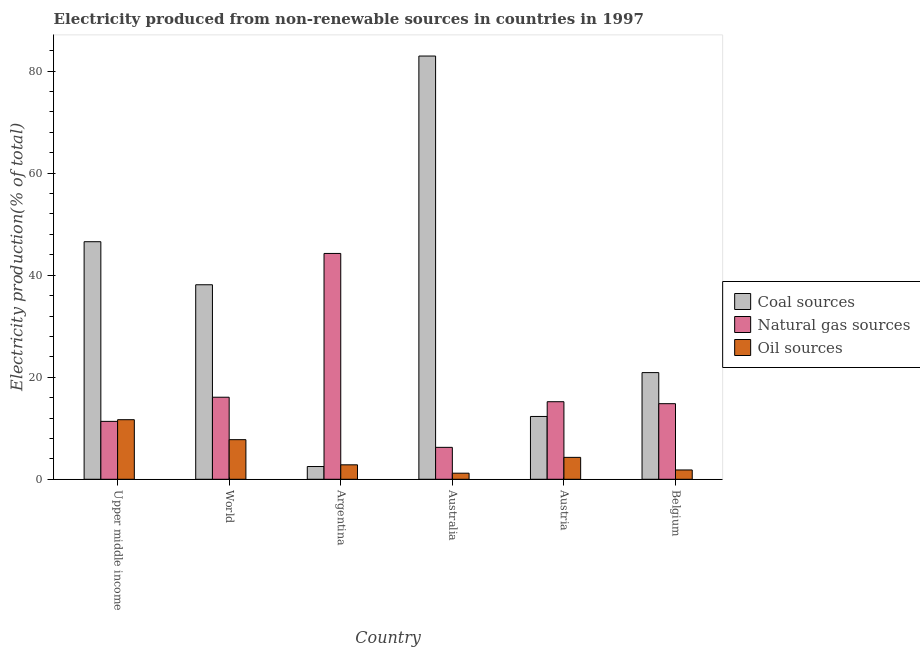Are the number of bars per tick equal to the number of legend labels?
Your response must be concise. Yes. Are the number of bars on each tick of the X-axis equal?
Offer a very short reply. Yes. How many bars are there on the 6th tick from the right?
Offer a terse response. 3. In how many cases, is the number of bars for a given country not equal to the number of legend labels?
Your answer should be very brief. 0. What is the percentage of electricity produced by coal in Argentina?
Make the answer very short. 2.5. Across all countries, what is the maximum percentage of electricity produced by natural gas?
Your answer should be very brief. 44.27. Across all countries, what is the minimum percentage of electricity produced by coal?
Provide a short and direct response. 2.5. In which country was the percentage of electricity produced by oil sources maximum?
Your answer should be compact. Upper middle income. What is the total percentage of electricity produced by natural gas in the graph?
Your answer should be very brief. 107.98. What is the difference between the percentage of electricity produced by oil sources in Argentina and that in Australia?
Your answer should be compact. 1.64. What is the difference between the percentage of electricity produced by natural gas in World and the percentage of electricity produced by oil sources in Austria?
Your response must be concise. 11.79. What is the average percentage of electricity produced by oil sources per country?
Your answer should be compact. 4.93. What is the difference between the percentage of electricity produced by natural gas and percentage of electricity produced by oil sources in Belgium?
Provide a succinct answer. 12.99. In how many countries, is the percentage of electricity produced by oil sources greater than 76 %?
Provide a short and direct response. 0. What is the ratio of the percentage of electricity produced by natural gas in Argentina to that in Austria?
Keep it short and to the point. 2.91. What is the difference between the highest and the second highest percentage of electricity produced by coal?
Offer a terse response. 36.4. What is the difference between the highest and the lowest percentage of electricity produced by natural gas?
Offer a terse response. 38.01. What does the 2nd bar from the left in Upper middle income represents?
Make the answer very short. Natural gas sources. What does the 3rd bar from the right in Austria represents?
Give a very brief answer. Coal sources. Is it the case that in every country, the sum of the percentage of electricity produced by coal and percentage of electricity produced by natural gas is greater than the percentage of electricity produced by oil sources?
Your answer should be very brief. Yes. How many bars are there?
Make the answer very short. 18. What is the difference between two consecutive major ticks on the Y-axis?
Ensure brevity in your answer.  20. Are the values on the major ticks of Y-axis written in scientific E-notation?
Your response must be concise. No. Does the graph contain grids?
Offer a terse response. No. Where does the legend appear in the graph?
Provide a succinct answer. Center right. How many legend labels are there?
Give a very brief answer. 3. How are the legend labels stacked?
Provide a short and direct response. Vertical. What is the title of the graph?
Ensure brevity in your answer.  Electricity produced from non-renewable sources in countries in 1997. Does "Secondary" appear as one of the legend labels in the graph?
Provide a succinct answer. No. What is the label or title of the X-axis?
Your answer should be compact. Country. What is the label or title of the Y-axis?
Make the answer very short. Electricity production(% of total). What is the Electricity production(% of total) of Coal sources in Upper middle income?
Your answer should be compact. 46.57. What is the Electricity production(% of total) in Natural gas sources in Upper middle income?
Give a very brief answer. 11.35. What is the Electricity production(% of total) of Oil sources in Upper middle income?
Ensure brevity in your answer.  11.68. What is the Electricity production(% of total) of Coal sources in World?
Offer a terse response. 38.13. What is the Electricity production(% of total) of Natural gas sources in World?
Your response must be concise. 16.08. What is the Electricity production(% of total) in Oil sources in World?
Keep it short and to the point. 7.76. What is the Electricity production(% of total) of Coal sources in Argentina?
Give a very brief answer. 2.5. What is the Electricity production(% of total) in Natural gas sources in Argentina?
Keep it short and to the point. 44.27. What is the Electricity production(% of total) of Oil sources in Argentina?
Provide a short and direct response. 2.83. What is the Electricity production(% of total) in Coal sources in Australia?
Ensure brevity in your answer.  82.96. What is the Electricity production(% of total) in Natural gas sources in Australia?
Your answer should be compact. 6.26. What is the Electricity production(% of total) in Oil sources in Australia?
Provide a succinct answer. 1.19. What is the Electricity production(% of total) of Coal sources in Austria?
Provide a short and direct response. 12.31. What is the Electricity production(% of total) in Natural gas sources in Austria?
Ensure brevity in your answer.  15.2. What is the Electricity production(% of total) in Oil sources in Austria?
Provide a succinct answer. 4.29. What is the Electricity production(% of total) of Coal sources in Belgium?
Your response must be concise. 20.91. What is the Electricity production(% of total) in Natural gas sources in Belgium?
Offer a terse response. 14.82. What is the Electricity production(% of total) in Oil sources in Belgium?
Your response must be concise. 1.83. Across all countries, what is the maximum Electricity production(% of total) of Coal sources?
Your answer should be very brief. 82.96. Across all countries, what is the maximum Electricity production(% of total) of Natural gas sources?
Keep it short and to the point. 44.27. Across all countries, what is the maximum Electricity production(% of total) of Oil sources?
Keep it short and to the point. 11.68. Across all countries, what is the minimum Electricity production(% of total) of Coal sources?
Provide a short and direct response. 2.5. Across all countries, what is the minimum Electricity production(% of total) in Natural gas sources?
Provide a short and direct response. 6.26. Across all countries, what is the minimum Electricity production(% of total) of Oil sources?
Provide a short and direct response. 1.19. What is the total Electricity production(% of total) in Coal sources in the graph?
Your answer should be very brief. 203.38. What is the total Electricity production(% of total) of Natural gas sources in the graph?
Provide a succinct answer. 107.98. What is the total Electricity production(% of total) of Oil sources in the graph?
Keep it short and to the point. 29.59. What is the difference between the Electricity production(% of total) of Coal sources in Upper middle income and that in World?
Provide a short and direct response. 8.44. What is the difference between the Electricity production(% of total) in Natural gas sources in Upper middle income and that in World?
Provide a succinct answer. -4.73. What is the difference between the Electricity production(% of total) of Oil sources in Upper middle income and that in World?
Give a very brief answer. 3.92. What is the difference between the Electricity production(% of total) in Coal sources in Upper middle income and that in Argentina?
Provide a short and direct response. 44.07. What is the difference between the Electricity production(% of total) of Natural gas sources in Upper middle income and that in Argentina?
Provide a succinct answer. -32.92. What is the difference between the Electricity production(% of total) of Oil sources in Upper middle income and that in Argentina?
Make the answer very short. 8.85. What is the difference between the Electricity production(% of total) of Coal sources in Upper middle income and that in Australia?
Offer a terse response. -36.4. What is the difference between the Electricity production(% of total) in Natural gas sources in Upper middle income and that in Australia?
Your answer should be very brief. 5.09. What is the difference between the Electricity production(% of total) in Oil sources in Upper middle income and that in Australia?
Offer a very short reply. 10.49. What is the difference between the Electricity production(% of total) in Coal sources in Upper middle income and that in Austria?
Make the answer very short. 34.25. What is the difference between the Electricity production(% of total) in Natural gas sources in Upper middle income and that in Austria?
Keep it short and to the point. -3.85. What is the difference between the Electricity production(% of total) of Oil sources in Upper middle income and that in Austria?
Make the answer very short. 7.39. What is the difference between the Electricity production(% of total) in Coal sources in Upper middle income and that in Belgium?
Make the answer very short. 25.65. What is the difference between the Electricity production(% of total) of Natural gas sources in Upper middle income and that in Belgium?
Give a very brief answer. -3.47. What is the difference between the Electricity production(% of total) of Oil sources in Upper middle income and that in Belgium?
Ensure brevity in your answer.  9.85. What is the difference between the Electricity production(% of total) of Coal sources in World and that in Argentina?
Ensure brevity in your answer.  35.63. What is the difference between the Electricity production(% of total) in Natural gas sources in World and that in Argentina?
Your answer should be very brief. -28.18. What is the difference between the Electricity production(% of total) in Oil sources in World and that in Argentina?
Your answer should be very brief. 4.93. What is the difference between the Electricity production(% of total) of Coal sources in World and that in Australia?
Your answer should be compact. -44.84. What is the difference between the Electricity production(% of total) in Natural gas sources in World and that in Australia?
Give a very brief answer. 9.82. What is the difference between the Electricity production(% of total) of Oil sources in World and that in Australia?
Make the answer very short. 6.57. What is the difference between the Electricity production(% of total) of Coal sources in World and that in Austria?
Ensure brevity in your answer.  25.81. What is the difference between the Electricity production(% of total) of Natural gas sources in World and that in Austria?
Ensure brevity in your answer.  0.88. What is the difference between the Electricity production(% of total) of Oil sources in World and that in Austria?
Your answer should be compact. 3.47. What is the difference between the Electricity production(% of total) of Coal sources in World and that in Belgium?
Ensure brevity in your answer.  17.22. What is the difference between the Electricity production(% of total) in Natural gas sources in World and that in Belgium?
Ensure brevity in your answer.  1.26. What is the difference between the Electricity production(% of total) in Oil sources in World and that in Belgium?
Offer a very short reply. 5.94. What is the difference between the Electricity production(% of total) of Coal sources in Argentina and that in Australia?
Give a very brief answer. -80.46. What is the difference between the Electricity production(% of total) of Natural gas sources in Argentina and that in Australia?
Keep it short and to the point. 38.01. What is the difference between the Electricity production(% of total) in Oil sources in Argentina and that in Australia?
Give a very brief answer. 1.64. What is the difference between the Electricity production(% of total) of Coal sources in Argentina and that in Austria?
Provide a succinct answer. -9.81. What is the difference between the Electricity production(% of total) in Natural gas sources in Argentina and that in Austria?
Your answer should be compact. 29.06. What is the difference between the Electricity production(% of total) in Oil sources in Argentina and that in Austria?
Ensure brevity in your answer.  -1.46. What is the difference between the Electricity production(% of total) in Coal sources in Argentina and that in Belgium?
Give a very brief answer. -18.41. What is the difference between the Electricity production(% of total) of Natural gas sources in Argentina and that in Belgium?
Provide a short and direct response. 29.45. What is the difference between the Electricity production(% of total) of Oil sources in Argentina and that in Belgium?
Your answer should be very brief. 1.01. What is the difference between the Electricity production(% of total) in Coal sources in Australia and that in Austria?
Give a very brief answer. 70.65. What is the difference between the Electricity production(% of total) of Natural gas sources in Australia and that in Austria?
Offer a terse response. -8.95. What is the difference between the Electricity production(% of total) in Oil sources in Australia and that in Austria?
Provide a succinct answer. -3.1. What is the difference between the Electricity production(% of total) in Coal sources in Australia and that in Belgium?
Make the answer very short. 62.05. What is the difference between the Electricity production(% of total) of Natural gas sources in Australia and that in Belgium?
Your answer should be compact. -8.56. What is the difference between the Electricity production(% of total) of Oil sources in Australia and that in Belgium?
Your answer should be compact. -0.64. What is the difference between the Electricity production(% of total) in Coal sources in Austria and that in Belgium?
Keep it short and to the point. -8.6. What is the difference between the Electricity production(% of total) in Natural gas sources in Austria and that in Belgium?
Make the answer very short. 0.39. What is the difference between the Electricity production(% of total) in Oil sources in Austria and that in Belgium?
Your response must be concise. 2.47. What is the difference between the Electricity production(% of total) in Coal sources in Upper middle income and the Electricity production(% of total) in Natural gas sources in World?
Your answer should be compact. 30.48. What is the difference between the Electricity production(% of total) of Coal sources in Upper middle income and the Electricity production(% of total) of Oil sources in World?
Your answer should be compact. 38.8. What is the difference between the Electricity production(% of total) of Natural gas sources in Upper middle income and the Electricity production(% of total) of Oil sources in World?
Ensure brevity in your answer.  3.59. What is the difference between the Electricity production(% of total) in Coal sources in Upper middle income and the Electricity production(% of total) in Natural gas sources in Argentina?
Ensure brevity in your answer.  2.3. What is the difference between the Electricity production(% of total) in Coal sources in Upper middle income and the Electricity production(% of total) in Oil sources in Argentina?
Give a very brief answer. 43.73. What is the difference between the Electricity production(% of total) in Natural gas sources in Upper middle income and the Electricity production(% of total) in Oil sources in Argentina?
Provide a short and direct response. 8.52. What is the difference between the Electricity production(% of total) of Coal sources in Upper middle income and the Electricity production(% of total) of Natural gas sources in Australia?
Your answer should be compact. 40.31. What is the difference between the Electricity production(% of total) in Coal sources in Upper middle income and the Electricity production(% of total) in Oil sources in Australia?
Make the answer very short. 45.38. What is the difference between the Electricity production(% of total) of Natural gas sources in Upper middle income and the Electricity production(% of total) of Oil sources in Australia?
Your answer should be very brief. 10.16. What is the difference between the Electricity production(% of total) in Coal sources in Upper middle income and the Electricity production(% of total) in Natural gas sources in Austria?
Your answer should be very brief. 31.36. What is the difference between the Electricity production(% of total) of Coal sources in Upper middle income and the Electricity production(% of total) of Oil sources in Austria?
Give a very brief answer. 42.27. What is the difference between the Electricity production(% of total) in Natural gas sources in Upper middle income and the Electricity production(% of total) in Oil sources in Austria?
Keep it short and to the point. 7.06. What is the difference between the Electricity production(% of total) of Coal sources in Upper middle income and the Electricity production(% of total) of Natural gas sources in Belgium?
Offer a terse response. 31.75. What is the difference between the Electricity production(% of total) in Coal sources in Upper middle income and the Electricity production(% of total) in Oil sources in Belgium?
Your answer should be very brief. 44.74. What is the difference between the Electricity production(% of total) of Natural gas sources in Upper middle income and the Electricity production(% of total) of Oil sources in Belgium?
Keep it short and to the point. 9.52. What is the difference between the Electricity production(% of total) in Coal sources in World and the Electricity production(% of total) in Natural gas sources in Argentina?
Your answer should be very brief. -6.14. What is the difference between the Electricity production(% of total) in Coal sources in World and the Electricity production(% of total) in Oil sources in Argentina?
Your answer should be very brief. 35.29. What is the difference between the Electricity production(% of total) of Natural gas sources in World and the Electricity production(% of total) of Oil sources in Argentina?
Make the answer very short. 13.25. What is the difference between the Electricity production(% of total) in Coal sources in World and the Electricity production(% of total) in Natural gas sources in Australia?
Give a very brief answer. 31.87. What is the difference between the Electricity production(% of total) in Coal sources in World and the Electricity production(% of total) in Oil sources in Australia?
Your answer should be very brief. 36.94. What is the difference between the Electricity production(% of total) of Natural gas sources in World and the Electricity production(% of total) of Oil sources in Australia?
Provide a succinct answer. 14.89. What is the difference between the Electricity production(% of total) of Coal sources in World and the Electricity production(% of total) of Natural gas sources in Austria?
Provide a short and direct response. 22.92. What is the difference between the Electricity production(% of total) of Coal sources in World and the Electricity production(% of total) of Oil sources in Austria?
Offer a terse response. 33.83. What is the difference between the Electricity production(% of total) of Natural gas sources in World and the Electricity production(% of total) of Oil sources in Austria?
Provide a short and direct response. 11.79. What is the difference between the Electricity production(% of total) in Coal sources in World and the Electricity production(% of total) in Natural gas sources in Belgium?
Make the answer very short. 23.31. What is the difference between the Electricity production(% of total) of Coal sources in World and the Electricity production(% of total) of Oil sources in Belgium?
Offer a very short reply. 36.3. What is the difference between the Electricity production(% of total) in Natural gas sources in World and the Electricity production(% of total) in Oil sources in Belgium?
Your answer should be compact. 14.26. What is the difference between the Electricity production(% of total) of Coal sources in Argentina and the Electricity production(% of total) of Natural gas sources in Australia?
Your response must be concise. -3.76. What is the difference between the Electricity production(% of total) of Coal sources in Argentina and the Electricity production(% of total) of Oil sources in Australia?
Ensure brevity in your answer.  1.31. What is the difference between the Electricity production(% of total) in Natural gas sources in Argentina and the Electricity production(% of total) in Oil sources in Australia?
Your answer should be very brief. 43.08. What is the difference between the Electricity production(% of total) of Coal sources in Argentina and the Electricity production(% of total) of Natural gas sources in Austria?
Make the answer very short. -12.7. What is the difference between the Electricity production(% of total) of Coal sources in Argentina and the Electricity production(% of total) of Oil sources in Austria?
Make the answer very short. -1.79. What is the difference between the Electricity production(% of total) of Natural gas sources in Argentina and the Electricity production(% of total) of Oil sources in Austria?
Keep it short and to the point. 39.97. What is the difference between the Electricity production(% of total) of Coal sources in Argentina and the Electricity production(% of total) of Natural gas sources in Belgium?
Provide a succinct answer. -12.32. What is the difference between the Electricity production(% of total) of Coal sources in Argentina and the Electricity production(% of total) of Oil sources in Belgium?
Offer a very short reply. 0.67. What is the difference between the Electricity production(% of total) in Natural gas sources in Argentina and the Electricity production(% of total) in Oil sources in Belgium?
Keep it short and to the point. 42.44. What is the difference between the Electricity production(% of total) in Coal sources in Australia and the Electricity production(% of total) in Natural gas sources in Austria?
Keep it short and to the point. 67.76. What is the difference between the Electricity production(% of total) in Coal sources in Australia and the Electricity production(% of total) in Oil sources in Austria?
Provide a succinct answer. 78.67. What is the difference between the Electricity production(% of total) in Natural gas sources in Australia and the Electricity production(% of total) in Oil sources in Austria?
Your answer should be very brief. 1.96. What is the difference between the Electricity production(% of total) of Coal sources in Australia and the Electricity production(% of total) of Natural gas sources in Belgium?
Keep it short and to the point. 68.15. What is the difference between the Electricity production(% of total) in Coal sources in Australia and the Electricity production(% of total) in Oil sources in Belgium?
Your answer should be compact. 81.14. What is the difference between the Electricity production(% of total) of Natural gas sources in Australia and the Electricity production(% of total) of Oil sources in Belgium?
Provide a short and direct response. 4.43. What is the difference between the Electricity production(% of total) in Coal sources in Austria and the Electricity production(% of total) in Natural gas sources in Belgium?
Keep it short and to the point. -2.5. What is the difference between the Electricity production(% of total) of Coal sources in Austria and the Electricity production(% of total) of Oil sources in Belgium?
Your answer should be very brief. 10.49. What is the difference between the Electricity production(% of total) of Natural gas sources in Austria and the Electricity production(% of total) of Oil sources in Belgium?
Provide a short and direct response. 13.38. What is the average Electricity production(% of total) of Coal sources per country?
Provide a succinct answer. 33.9. What is the average Electricity production(% of total) in Natural gas sources per country?
Give a very brief answer. 18. What is the average Electricity production(% of total) of Oil sources per country?
Give a very brief answer. 4.93. What is the difference between the Electricity production(% of total) of Coal sources and Electricity production(% of total) of Natural gas sources in Upper middle income?
Provide a succinct answer. 35.22. What is the difference between the Electricity production(% of total) in Coal sources and Electricity production(% of total) in Oil sources in Upper middle income?
Offer a terse response. 34.89. What is the difference between the Electricity production(% of total) of Natural gas sources and Electricity production(% of total) of Oil sources in Upper middle income?
Keep it short and to the point. -0.33. What is the difference between the Electricity production(% of total) of Coal sources and Electricity production(% of total) of Natural gas sources in World?
Your answer should be very brief. 22.05. What is the difference between the Electricity production(% of total) in Coal sources and Electricity production(% of total) in Oil sources in World?
Ensure brevity in your answer.  30.36. What is the difference between the Electricity production(% of total) in Natural gas sources and Electricity production(% of total) in Oil sources in World?
Your answer should be very brief. 8.32. What is the difference between the Electricity production(% of total) of Coal sources and Electricity production(% of total) of Natural gas sources in Argentina?
Offer a terse response. -41.77. What is the difference between the Electricity production(% of total) of Coal sources and Electricity production(% of total) of Oil sources in Argentina?
Keep it short and to the point. -0.33. What is the difference between the Electricity production(% of total) of Natural gas sources and Electricity production(% of total) of Oil sources in Argentina?
Your answer should be very brief. 41.43. What is the difference between the Electricity production(% of total) in Coal sources and Electricity production(% of total) in Natural gas sources in Australia?
Your answer should be very brief. 76.71. What is the difference between the Electricity production(% of total) of Coal sources and Electricity production(% of total) of Oil sources in Australia?
Your answer should be very brief. 81.77. What is the difference between the Electricity production(% of total) in Natural gas sources and Electricity production(% of total) in Oil sources in Australia?
Keep it short and to the point. 5.07. What is the difference between the Electricity production(% of total) in Coal sources and Electricity production(% of total) in Natural gas sources in Austria?
Provide a short and direct response. -2.89. What is the difference between the Electricity production(% of total) in Coal sources and Electricity production(% of total) in Oil sources in Austria?
Offer a very short reply. 8.02. What is the difference between the Electricity production(% of total) in Natural gas sources and Electricity production(% of total) in Oil sources in Austria?
Your answer should be compact. 10.91. What is the difference between the Electricity production(% of total) of Coal sources and Electricity production(% of total) of Natural gas sources in Belgium?
Keep it short and to the point. 6.09. What is the difference between the Electricity production(% of total) of Coal sources and Electricity production(% of total) of Oil sources in Belgium?
Offer a very short reply. 19.09. What is the difference between the Electricity production(% of total) of Natural gas sources and Electricity production(% of total) of Oil sources in Belgium?
Provide a short and direct response. 12.99. What is the ratio of the Electricity production(% of total) in Coal sources in Upper middle income to that in World?
Your response must be concise. 1.22. What is the ratio of the Electricity production(% of total) of Natural gas sources in Upper middle income to that in World?
Keep it short and to the point. 0.71. What is the ratio of the Electricity production(% of total) in Oil sources in Upper middle income to that in World?
Provide a short and direct response. 1.5. What is the ratio of the Electricity production(% of total) of Coal sources in Upper middle income to that in Argentina?
Keep it short and to the point. 18.62. What is the ratio of the Electricity production(% of total) of Natural gas sources in Upper middle income to that in Argentina?
Your answer should be compact. 0.26. What is the ratio of the Electricity production(% of total) in Oil sources in Upper middle income to that in Argentina?
Keep it short and to the point. 4.12. What is the ratio of the Electricity production(% of total) in Coal sources in Upper middle income to that in Australia?
Keep it short and to the point. 0.56. What is the ratio of the Electricity production(% of total) in Natural gas sources in Upper middle income to that in Australia?
Keep it short and to the point. 1.81. What is the ratio of the Electricity production(% of total) of Oil sources in Upper middle income to that in Australia?
Provide a short and direct response. 9.81. What is the ratio of the Electricity production(% of total) of Coal sources in Upper middle income to that in Austria?
Provide a succinct answer. 3.78. What is the ratio of the Electricity production(% of total) of Natural gas sources in Upper middle income to that in Austria?
Your response must be concise. 0.75. What is the ratio of the Electricity production(% of total) of Oil sources in Upper middle income to that in Austria?
Ensure brevity in your answer.  2.72. What is the ratio of the Electricity production(% of total) of Coal sources in Upper middle income to that in Belgium?
Your response must be concise. 2.23. What is the ratio of the Electricity production(% of total) of Natural gas sources in Upper middle income to that in Belgium?
Make the answer very short. 0.77. What is the ratio of the Electricity production(% of total) in Oil sources in Upper middle income to that in Belgium?
Offer a very short reply. 6.39. What is the ratio of the Electricity production(% of total) in Coal sources in World to that in Argentina?
Offer a very short reply. 15.25. What is the ratio of the Electricity production(% of total) of Natural gas sources in World to that in Argentina?
Make the answer very short. 0.36. What is the ratio of the Electricity production(% of total) in Oil sources in World to that in Argentina?
Give a very brief answer. 2.74. What is the ratio of the Electricity production(% of total) of Coal sources in World to that in Australia?
Offer a terse response. 0.46. What is the ratio of the Electricity production(% of total) in Natural gas sources in World to that in Australia?
Offer a very short reply. 2.57. What is the ratio of the Electricity production(% of total) of Oil sources in World to that in Australia?
Ensure brevity in your answer.  6.52. What is the ratio of the Electricity production(% of total) of Coal sources in World to that in Austria?
Keep it short and to the point. 3.1. What is the ratio of the Electricity production(% of total) of Natural gas sources in World to that in Austria?
Keep it short and to the point. 1.06. What is the ratio of the Electricity production(% of total) of Oil sources in World to that in Austria?
Your answer should be compact. 1.81. What is the ratio of the Electricity production(% of total) in Coal sources in World to that in Belgium?
Offer a terse response. 1.82. What is the ratio of the Electricity production(% of total) in Natural gas sources in World to that in Belgium?
Your response must be concise. 1.09. What is the ratio of the Electricity production(% of total) in Oil sources in World to that in Belgium?
Keep it short and to the point. 4.25. What is the ratio of the Electricity production(% of total) of Coal sources in Argentina to that in Australia?
Provide a succinct answer. 0.03. What is the ratio of the Electricity production(% of total) of Natural gas sources in Argentina to that in Australia?
Offer a terse response. 7.07. What is the ratio of the Electricity production(% of total) of Oil sources in Argentina to that in Australia?
Your response must be concise. 2.38. What is the ratio of the Electricity production(% of total) in Coal sources in Argentina to that in Austria?
Your response must be concise. 0.2. What is the ratio of the Electricity production(% of total) of Natural gas sources in Argentina to that in Austria?
Your answer should be compact. 2.91. What is the ratio of the Electricity production(% of total) of Oil sources in Argentina to that in Austria?
Your answer should be very brief. 0.66. What is the ratio of the Electricity production(% of total) in Coal sources in Argentina to that in Belgium?
Give a very brief answer. 0.12. What is the ratio of the Electricity production(% of total) in Natural gas sources in Argentina to that in Belgium?
Your answer should be very brief. 2.99. What is the ratio of the Electricity production(% of total) of Oil sources in Argentina to that in Belgium?
Provide a short and direct response. 1.55. What is the ratio of the Electricity production(% of total) in Coal sources in Australia to that in Austria?
Offer a terse response. 6.74. What is the ratio of the Electricity production(% of total) in Natural gas sources in Australia to that in Austria?
Offer a terse response. 0.41. What is the ratio of the Electricity production(% of total) in Oil sources in Australia to that in Austria?
Give a very brief answer. 0.28. What is the ratio of the Electricity production(% of total) of Coal sources in Australia to that in Belgium?
Give a very brief answer. 3.97. What is the ratio of the Electricity production(% of total) of Natural gas sources in Australia to that in Belgium?
Provide a succinct answer. 0.42. What is the ratio of the Electricity production(% of total) in Oil sources in Australia to that in Belgium?
Ensure brevity in your answer.  0.65. What is the ratio of the Electricity production(% of total) of Coal sources in Austria to that in Belgium?
Give a very brief answer. 0.59. What is the ratio of the Electricity production(% of total) of Natural gas sources in Austria to that in Belgium?
Offer a very short reply. 1.03. What is the ratio of the Electricity production(% of total) of Oil sources in Austria to that in Belgium?
Ensure brevity in your answer.  2.35. What is the difference between the highest and the second highest Electricity production(% of total) of Coal sources?
Offer a terse response. 36.4. What is the difference between the highest and the second highest Electricity production(% of total) in Natural gas sources?
Ensure brevity in your answer.  28.18. What is the difference between the highest and the second highest Electricity production(% of total) in Oil sources?
Offer a very short reply. 3.92. What is the difference between the highest and the lowest Electricity production(% of total) of Coal sources?
Your answer should be very brief. 80.46. What is the difference between the highest and the lowest Electricity production(% of total) in Natural gas sources?
Make the answer very short. 38.01. What is the difference between the highest and the lowest Electricity production(% of total) in Oil sources?
Ensure brevity in your answer.  10.49. 